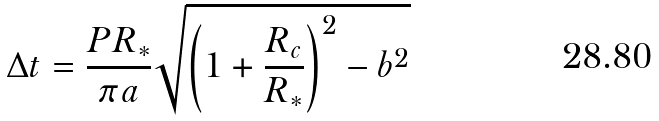Convert formula to latex. <formula><loc_0><loc_0><loc_500><loc_500>\Delta t = \frac { P R _ { * } } { \pi a } \sqrt { \left ( 1 + \frac { R _ { c } } { R _ { * } } \right ) ^ { 2 } - b ^ { 2 } }</formula> 